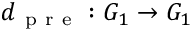<formula> <loc_0><loc_0><loc_500><loc_500>d _ { p r e } \colon G _ { 1 } \to G _ { 1 }</formula> 